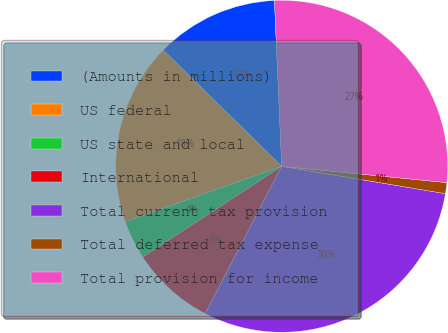Convert chart. <chart><loc_0><loc_0><loc_500><loc_500><pie_chart><fcel>(Amounts in millions)<fcel>US federal<fcel>US state and local<fcel>International<fcel>Total current tax provision<fcel>Total deferred tax expense<fcel>Total provision for income<nl><fcel>11.96%<fcel>17.77%<fcel>3.79%<fcel>8.16%<fcel>29.99%<fcel>1.07%<fcel>27.26%<nl></chart> 